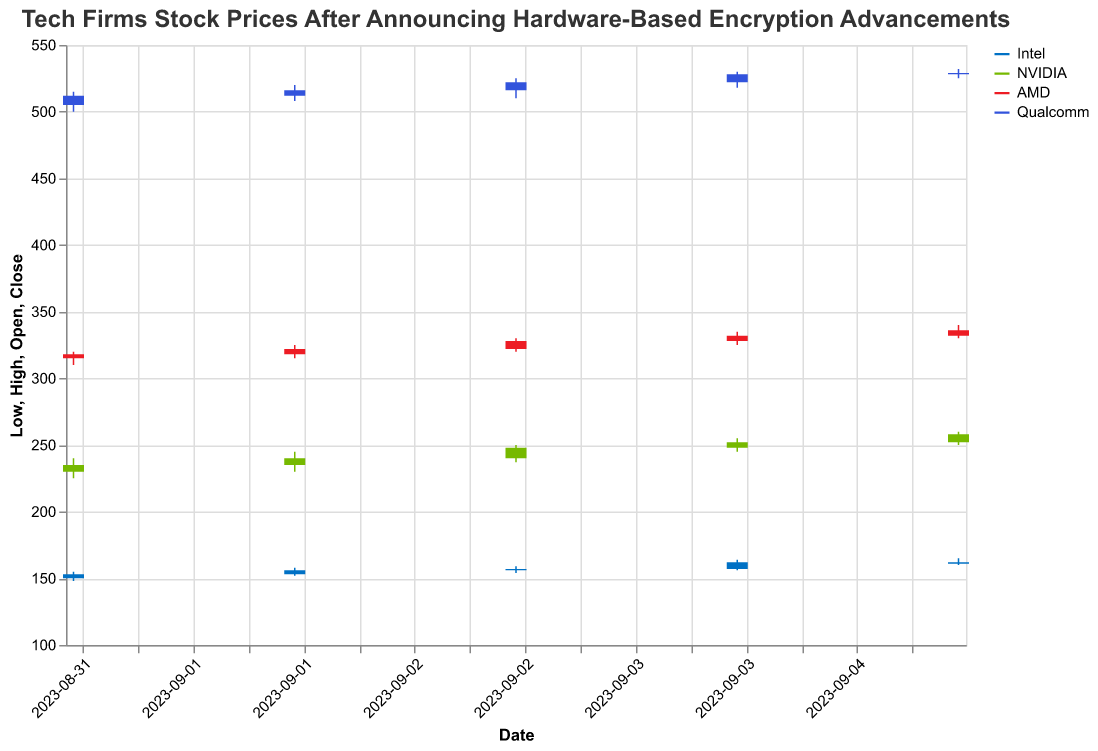What is the highest closing price for NVIDIA on any given day? Look at all the closing prices for NVIDIA and identify the highest value. The prices are 235.0, 240.0, 248.0, 252.0, and 258.0. The highest value is 258.0.
Answer: 258.0 Which company had the highest opening price on September 1st, 2023? Compare the opening prices of all companies on September 1st, 2023. Intel opened at 150.0, NVIDIA at 230.0, AMD at 315.0, and Qualcomm at 505.0. The highest opening price is for Qualcomm.
Answer: Qualcomm What was the difference between the opening and closing prices for Intel on September 5th, 2023? The opening price for Intel on September 5th is 162.0 and the closing price is 161.0. The difference is calculated as 162.0 - 161.0.
Answer: 1.0 How many trading days of data are available for AMD? Count the number of unique dates for which AMD's stock prices are available. The dates are September 1, 2, 3, 4, and 5. There are 5 trading days.
Answer: 5 What was the range (difference between high and low prices) for Qualcomm on September 3rd, 2023? Identify the high and low prices for Qualcomm on September 3rd. The high price is 525.0 and the low price is 510.0. The range is calculated as 525.0 - 510.0.
Answer: 15.0 Which company had the lowest volume of trading on September 4th, 2023? Compare the volumes of trading for all companies on September 4th. Intel had 3,000,000, NVIDIA had 6,000,000, AMD had 4,000,000, and Qualcomm had 5,300,000. Intel had the lowest trading volume.
Answer: Intel What was the average closing price for AMD across all trading days? Add up all the closing prices for AMD and divide by the number of trading days. The sum is 318.0 + 322.0 + 328.0 + 332.0 + 336.0 = 1636.0. Divide by 5 to get the average.
Answer: 327.2 Which company's stock saw the biggest increase in closing price from September 1st to September 5th, 2023? Calculate the difference in closing prices from September 1 to September 5 for each company. Intel: 161.0 - 153.0 = 8.0, NVIDIA: 258.0 - 235.0 = 23.0, AMD: 336.0 - 318.0 = 18.0, Qualcomm: 529.0 - 512.0 = 17.0. NVIDIA had the biggest increase.
Answer: NVIDIA 